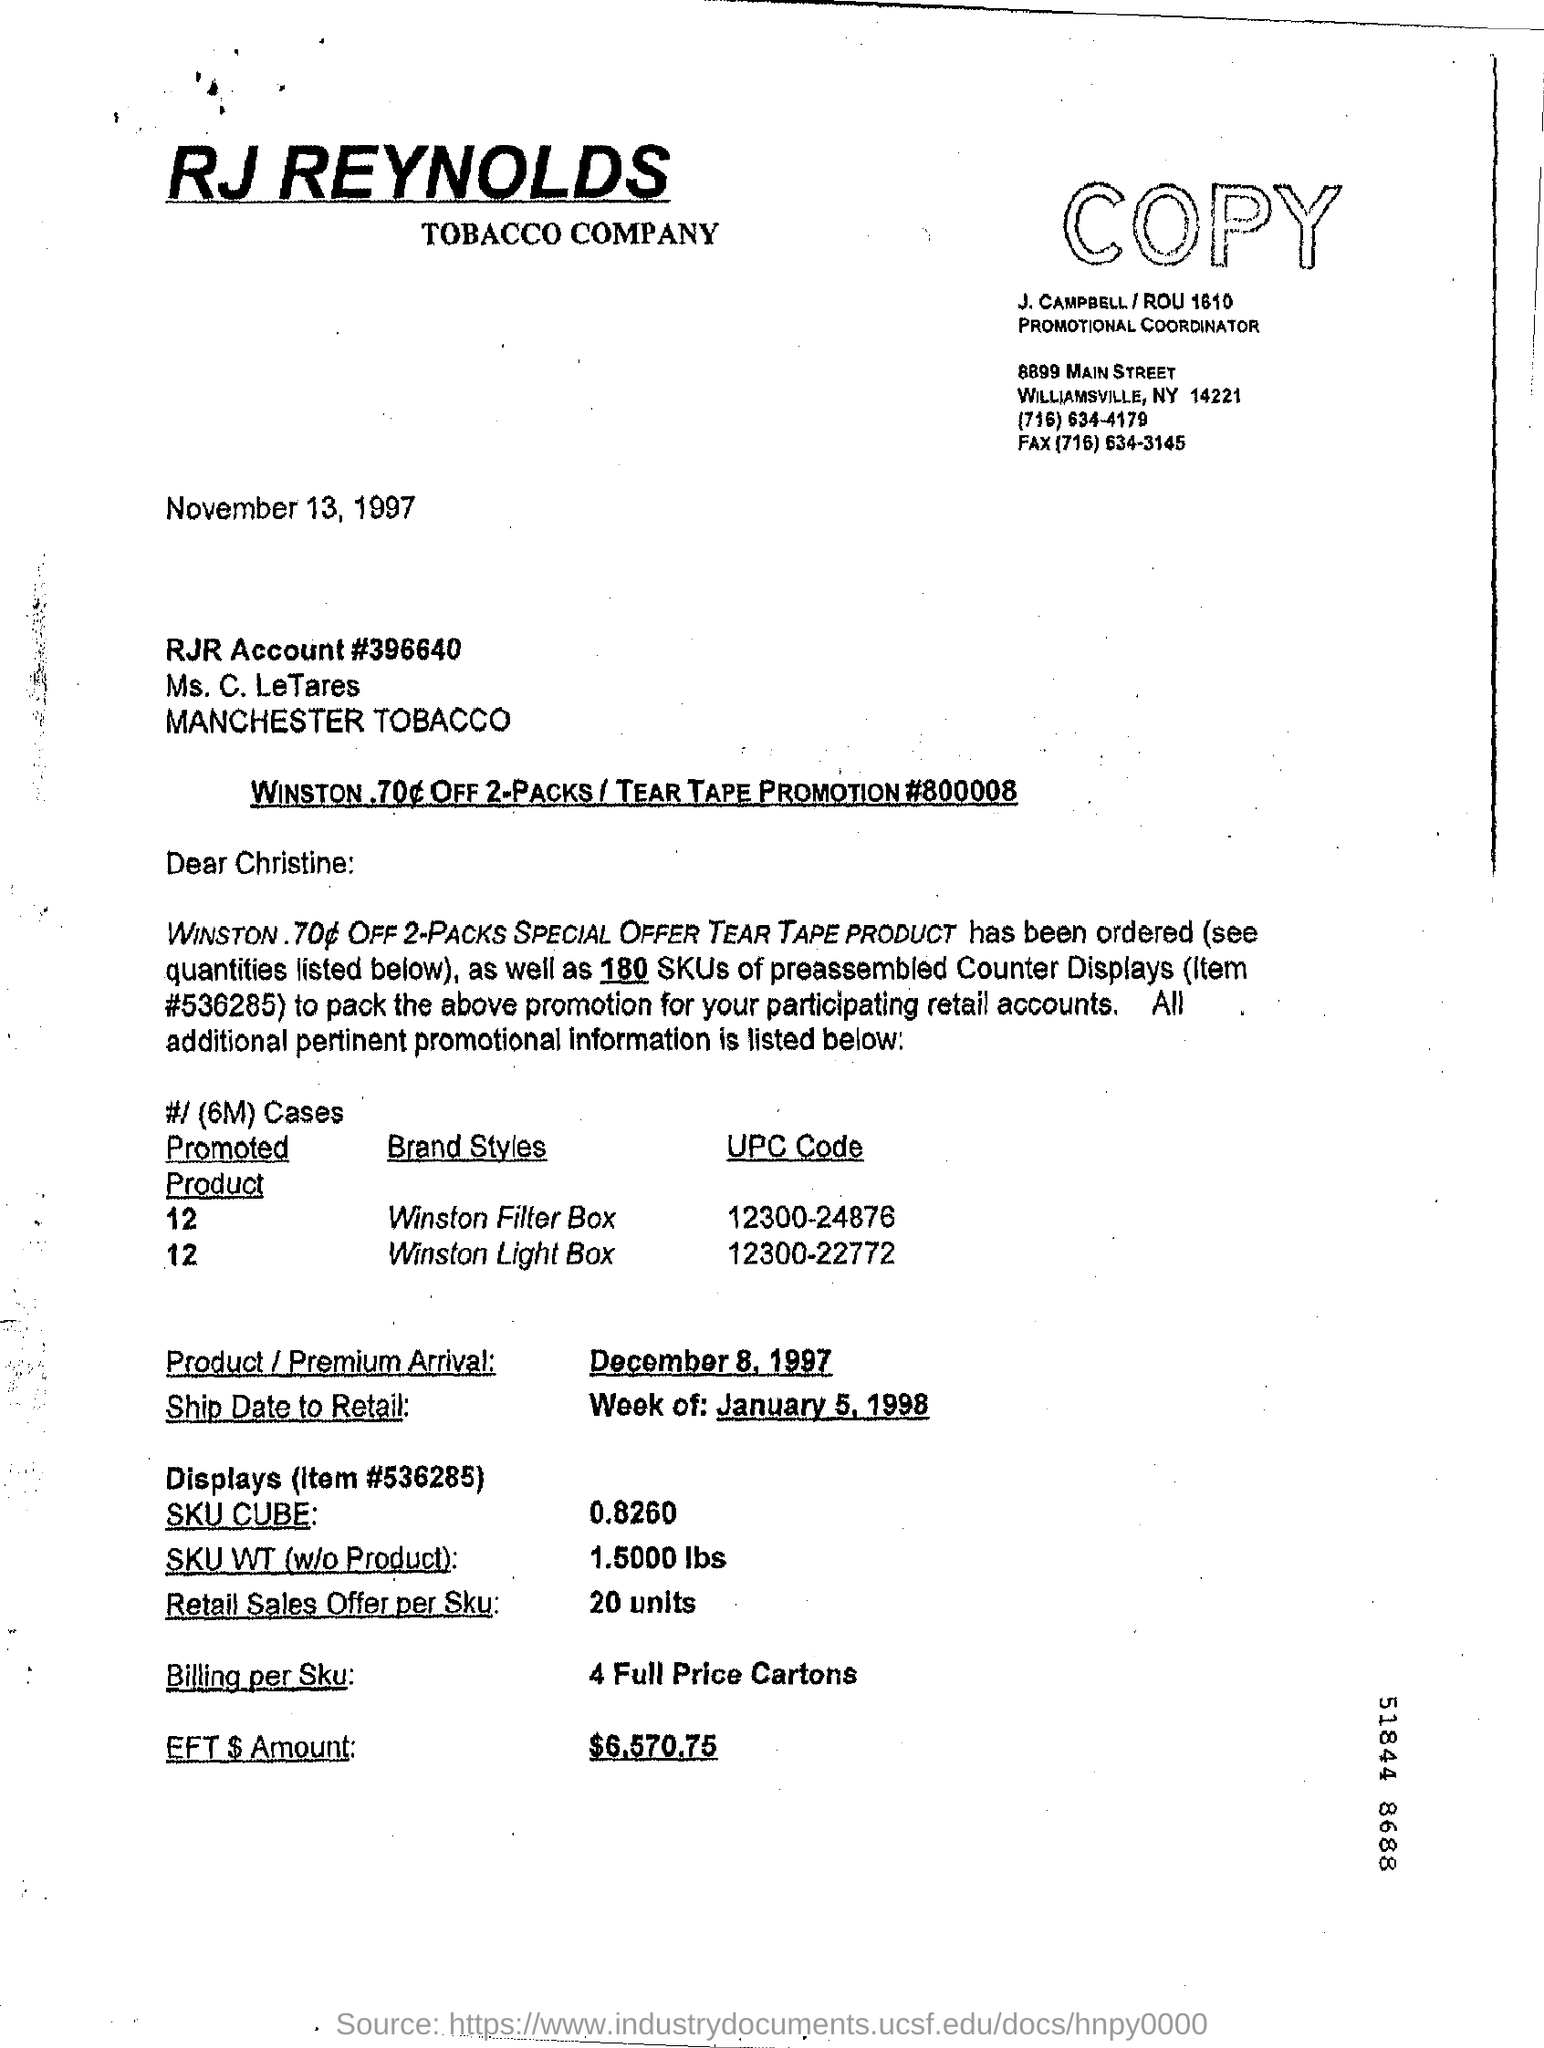What is the date on the document?
Provide a succinct answer. November 13, 1997. What is the Ship Date to Retail?
Your response must be concise. Week of : january 5 , 1998. What is the Retail Sales offer per SKU?
Your answer should be very brief. 20 units. What is the EFT $ Amount?
Your answer should be very brief. $6,570.75. 